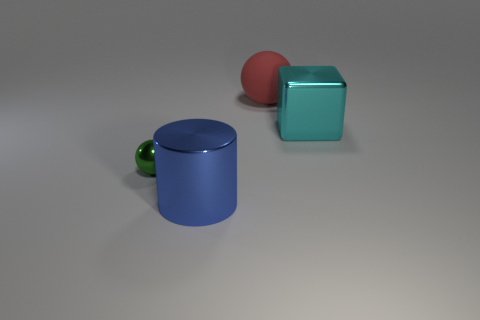Add 4 big yellow rubber cubes. How many objects exist? 8 Subtract all green spheres. How many spheres are left? 1 Add 3 big gray shiny spheres. How many big gray shiny spheres exist? 3 Subtract 0 green blocks. How many objects are left? 4 Subtract all cylinders. How many objects are left? 3 Subtract all blue balls. Subtract all yellow cubes. How many balls are left? 2 Subtract all big cyan objects. Subtract all tiny spheres. How many objects are left? 2 Add 2 blue metallic cylinders. How many blue metallic cylinders are left? 3 